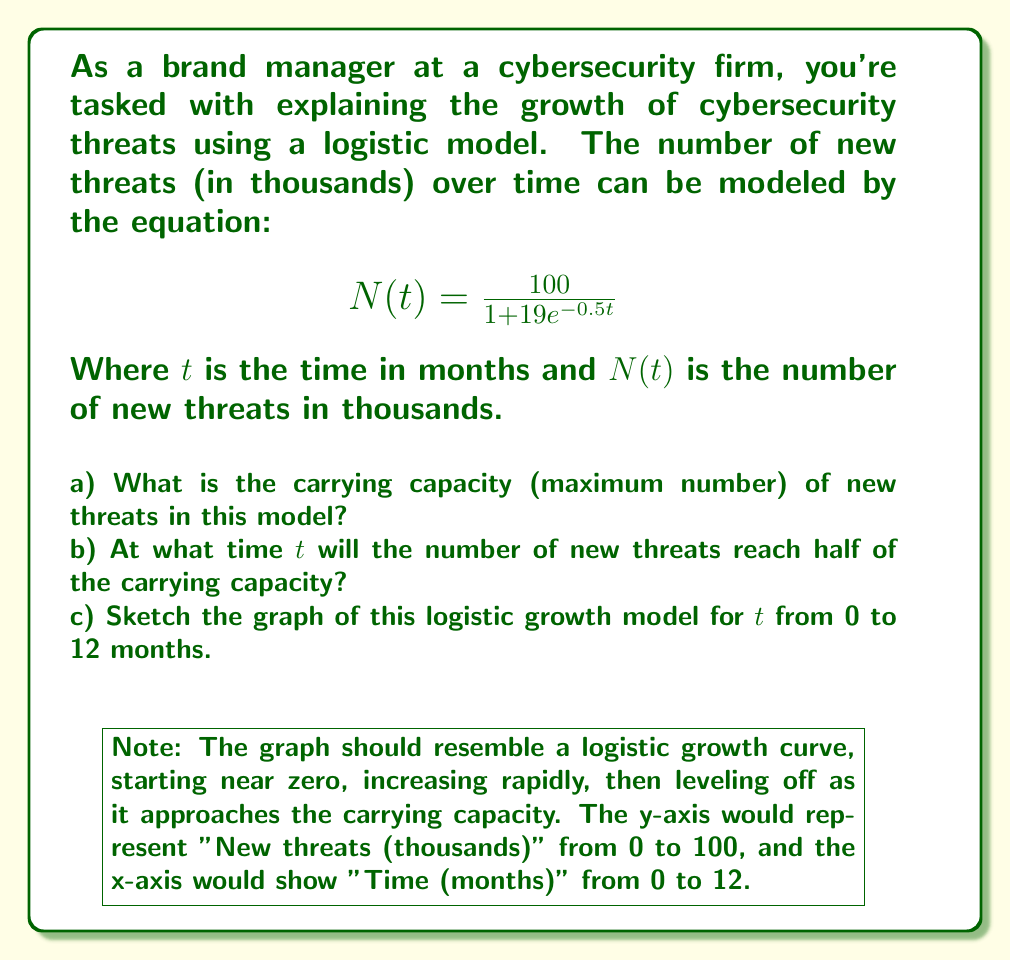Solve this math problem. Let's approach this step-by-step:

a) The carrying capacity in a logistic model is the value that $N(t)$ approaches as $t$ goes to infinity. In the given equation:

   $$N(t) = \frac{100}{1 + 19e^{-0.5t}}$$

   As $t$ approaches infinity, $e^{-0.5t}$ approaches 0, so the denominator approaches 1.
   Therefore, the carrying capacity is 100 thousand new threats.

b) To find when the number of threats is half the carrying capacity, we set $N(t) = 50$:

   $$50 = \frac{100}{1 + 19e^{-0.5t}}$$

   Solving for $t$:
   
   $$1 + 19e^{-0.5t} = 2$$
   $$19e^{-0.5t} = 1$$
   $$e^{-0.5t} = \frac{1}{19}$$
   $$-0.5t = \ln(\frac{1}{19})$$
   $$t = -2\ln(\frac{1}{19}) \approx 5.92$$

   So, the number of threats will reach half the carrying capacity after about 5.92 months.

c) The graph is provided in the question. It shows the characteristic S-shape of logistic growth, starting slowly, then increasing rapidly, and finally leveling off as it approaches the carrying capacity of 100 thousand threats.
Answer: a) 100 thousand threats
b) 5.92 months
c) S-shaped curve from 0 to 100 thousand over 12 months 